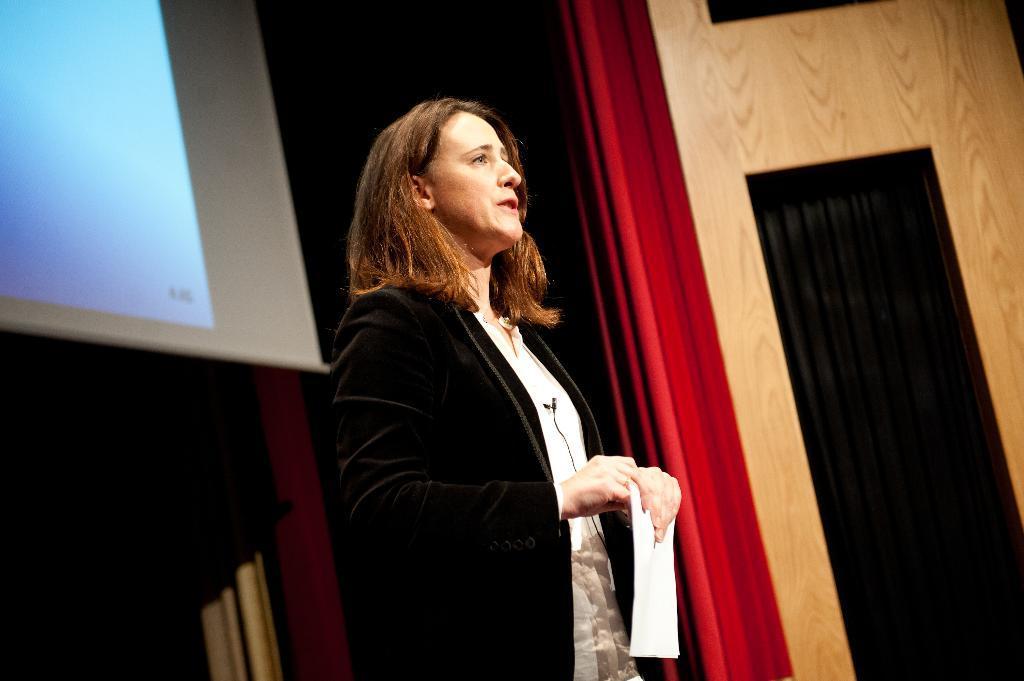Can you describe this image briefly? In this picture we can see a woman, she is holding a paper in her hands, in the background we can find curtains and a projector screen. 